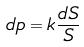Convert formula to latex. <formula><loc_0><loc_0><loc_500><loc_500>d p = k \frac { d S } { S }</formula> 